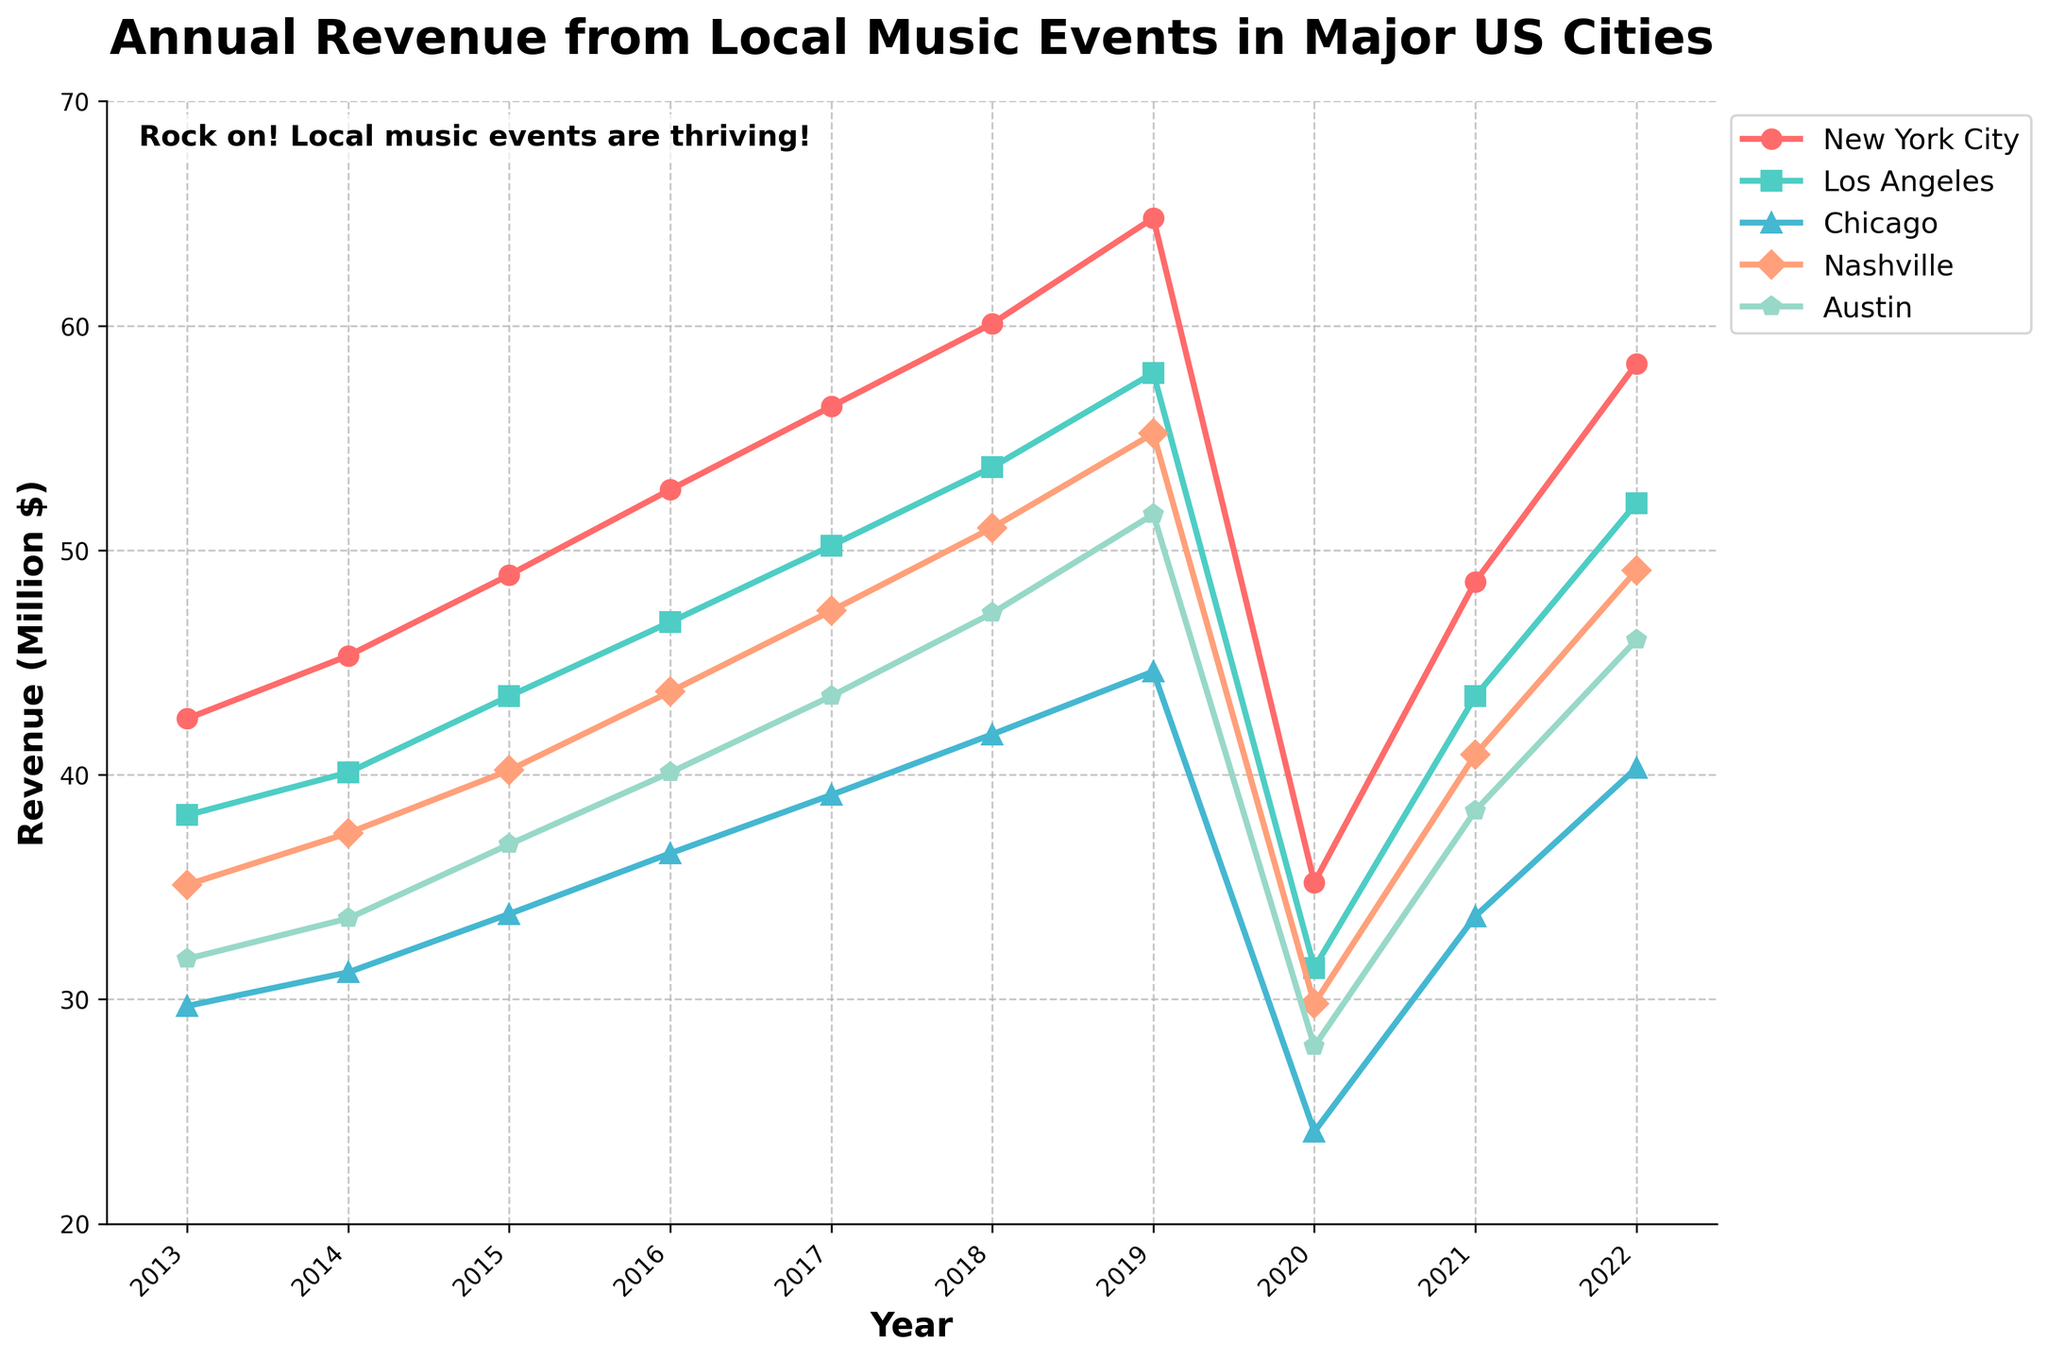Which city experienced the highest revenue in 2022? Look at the end of each line on the right side of the graph, corresponding to the year 2022. Identify the line that reaches the highest point.
Answer: New York City How did Nashville's revenue change from 2019 to 2020? Locate Nashville's line and compare its position in 2019 and 2020. The line drops from a higher to a lower point. Subtract 29.8 from 55.2 to get the decrease.
Answer: -25.4 million $ Which two cities had nearly identical revenues in 2021? Identify the points for each city in 2021, then compare their positions. Nashville and Los Angeles have almost identical points.
Answer: Neither Nashville nor Los Angeles Which city showed the most consistent revenue increase from 2013 to 2019? Trace each city's line from 2013 to 2019 and observe the smoothest upward trend. New York City's line is almost a straight positive slope.
Answer: New York City What is the approximate average revenue for Austin over the years presented? Add up Austin's revenue for all given years (31.8 + 33.6 + 36.9 + 40.1 + 43.5 + 47.2 + 51.6 + 27.9 + 38.4 + 46.0), then divide by the number of years (10). (31.8 + 33.6 + 36.9 + 40.1 + 43.5 + 47.2 + 51.6 + 27.9 + 38.4 + 46.0) / 10 = 39.7
Answer: 39.7 million $ In which year did the maximum drop in revenue occur for all cities? Look for the year where all lines drop sharply. This occurs between 2019 and 2020.
Answer: 2020 Which city had the second-highest revenue in 2016? Identify the points for each city in 2016 and arrange the values in descending order: New York City, Los Angeles, Nashville, Austin, Chicago. Nashville is second highest.
Answer: Los Angeles How much did revenues increase for Chicago from 2013 to 2019? Subtract Chicago's revenue in 2019 (44.6) from its revenue in 2013 (29.7). The result is 44.6 - 29.7 = 14.9.
Answer: 14.9 million $ In which year was Austin's revenue closest to 50 million? Find the point on Austin's line closest to the 50 on the y-axis. This occurs in 2019 with revenue at 51.6 million.
Answer: 2019 How many cities surpassed 50 million in revenue in 2022? Count the number of lines that cross the 50 million mark on the right side of the graph. Three cities (New York City, Los Angeles, Nashville) surpass 50 million.
Answer: 3 